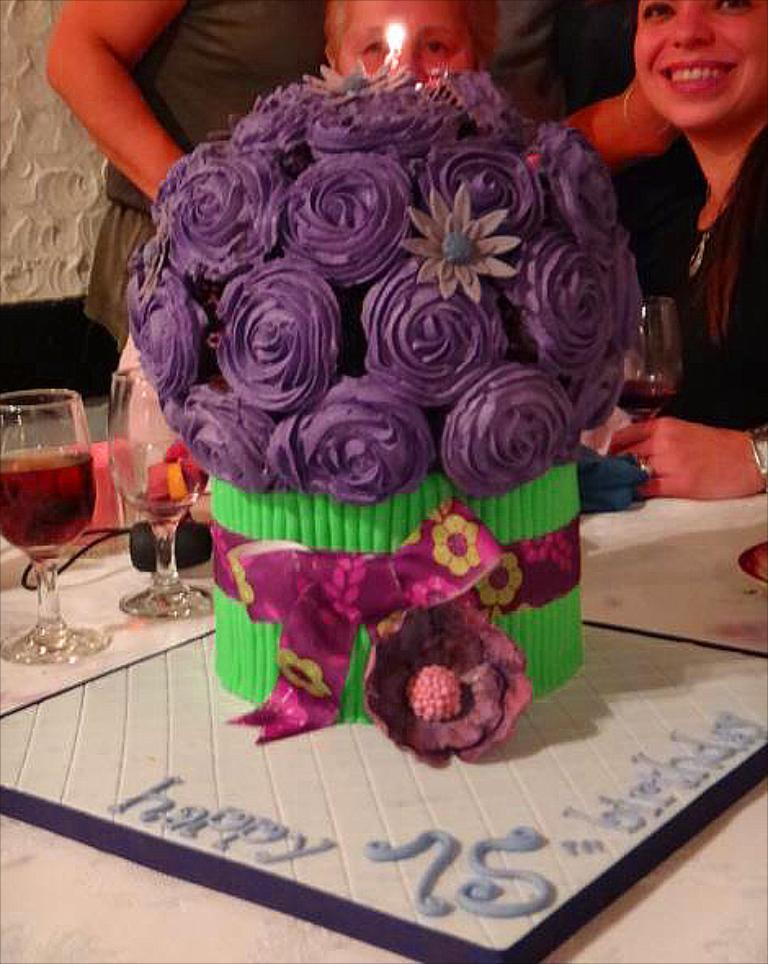How many people are in the image? There are two people in the image. Can you describe the facial expression of one of the people? One of the people is smiling. What object is in front of the people? There is a cake in front of the people. What type of design can be seen on the bean in the image? There is no bean present in the image, and therefore no design can be observed. 